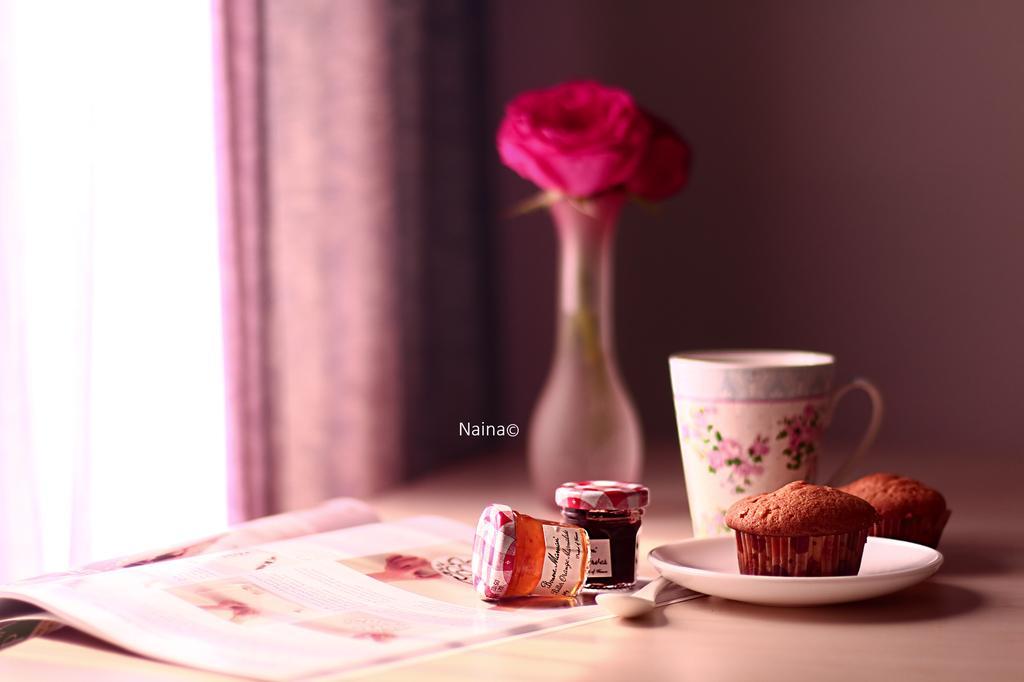Could you give a brief overview of what you see in this image? In this picture we can see a plate, a cake on the plate, in the back side there is a cup and flower pot, in the left side of image we can see a curtain, there is a paper on the table. 